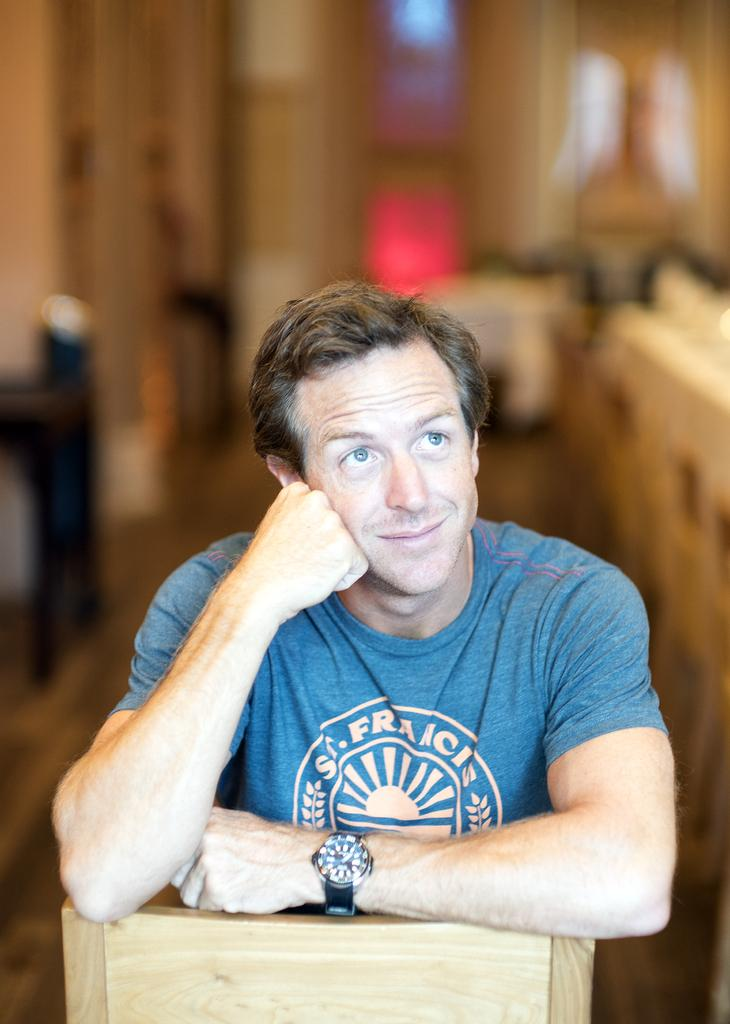Who is the main subject in the image? There is a man in the image. What object can be seen in the image besides the man? There is an object that looks like a chair in the image. Can you describe the background of the image? The background of the image is blurred. What type of lock can be seen on the chair in the image? There is no lock present on the chair in the image. How many beetles are crawling on the man in the image? There are no beetles present on the man in the image. 